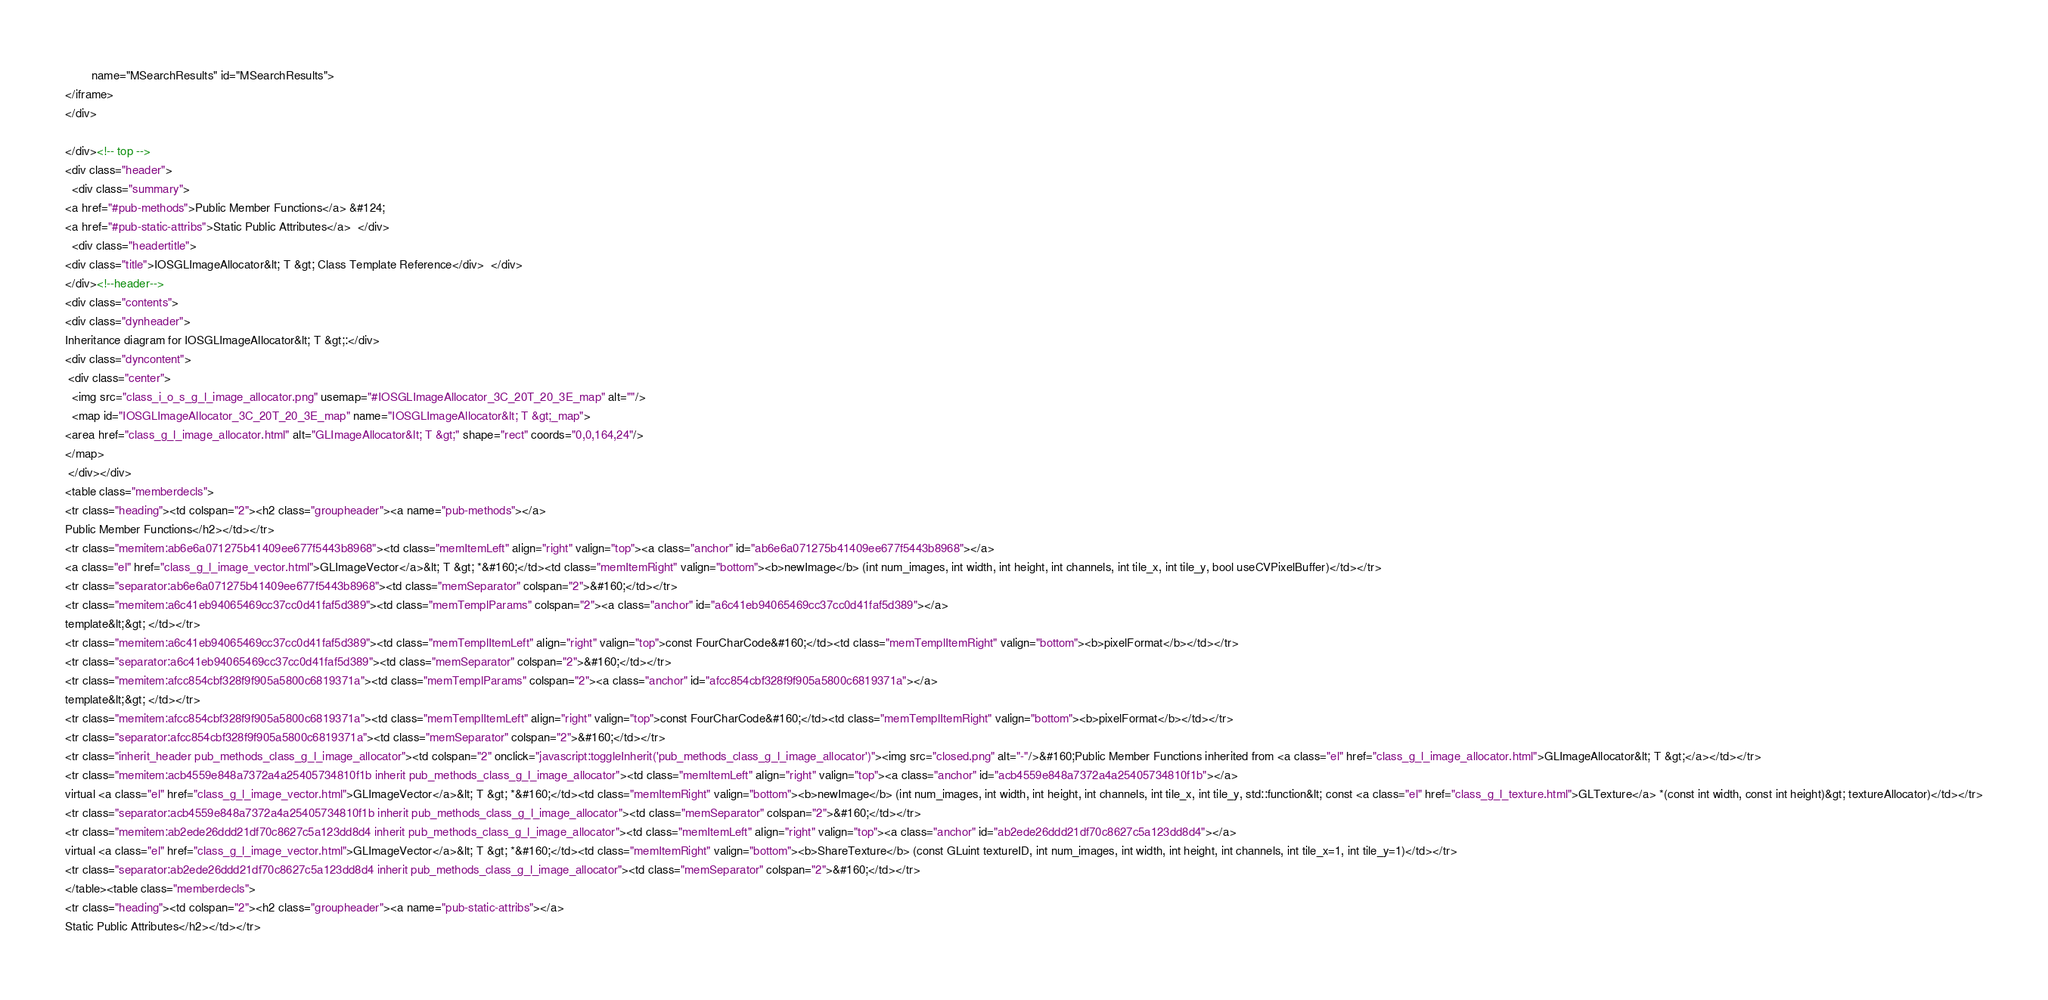Convert code to text. <code><loc_0><loc_0><loc_500><loc_500><_HTML_>        name="MSearchResults" id="MSearchResults">
</iframe>
</div>

</div><!-- top -->
<div class="header">
  <div class="summary">
<a href="#pub-methods">Public Member Functions</a> &#124;
<a href="#pub-static-attribs">Static Public Attributes</a>  </div>
  <div class="headertitle">
<div class="title">IOSGLImageAllocator&lt; T &gt; Class Template Reference</div>  </div>
</div><!--header-->
<div class="contents">
<div class="dynheader">
Inheritance diagram for IOSGLImageAllocator&lt; T &gt;:</div>
<div class="dyncontent">
 <div class="center">
  <img src="class_i_o_s_g_l_image_allocator.png" usemap="#IOSGLImageAllocator_3C_20T_20_3E_map" alt=""/>
  <map id="IOSGLImageAllocator_3C_20T_20_3E_map" name="IOSGLImageAllocator&lt; T &gt;_map">
<area href="class_g_l_image_allocator.html" alt="GLImageAllocator&lt; T &gt;" shape="rect" coords="0,0,164,24"/>
</map>
 </div></div>
<table class="memberdecls">
<tr class="heading"><td colspan="2"><h2 class="groupheader"><a name="pub-methods"></a>
Public Member Functions</h2></td></tr>
<tr class="memitem:ab6e6a071275b41409ee677f5443b8968"><td class="memItemLeft" align="right" valign="top"><a class="anchor" id="ab6e6a071275b41409ee677f5443b8968"></a>
<a class="el" href="class_g_l_image_vector.html">GLImageVector</a>&lt; T &gt; *&#160;</td><td class="memItemRight" valign="bottom"><b>newImage</b> (int num_images, int width, int height, int channels, int tile_x, int tile_y, bool useCVPixelBuffer)</td></tr>
<tr class="separator:ab6e6a071275b41409ee677f5443b8968"><td class="memSeparator" colspan="2">&#160;</td></tr>
<tr class="memitem:a6c41eb94065469cc37cc0d41faf5d389"><td class="memTemplParams" colspan="2"><a class="anchor" id="a6c41eb94065469cc37cc0d41faf5d389"></a>
template&lt;&gt; </td></tr>
<tr class="memitem:a6c41eb94065469cc37cc0d41faf5d389"><td class="memTemplItemLeft" align="right" valign="top">const FourCharCode&#160;</td><td class="memTemplItemRight" valign="bottom"><b>pixelFormat</b></td></tr>
<tr class="separator:a6c41eb94065469cc37cc0d41faf5d389"><td class="memSeparator" colspan="2">&#160;</td></tr>
<tr class="memitem:afcc854cbf328f9f905a5800c6819371a"><td class="memTemplParams" colspan="2"><a class="anchor" id="afcc854cbf328f9f905a5800c6819371a"></a>
template&lt;&gt; </td></tr>
<tr class="memitem:afcc854cbf328f9f905a5800c6819371a"><td class="memTemplItemLeft" align="right" valign="top">const FourCharCode&#160;</td><td class="memTemplItemRight" valign="bottom"><b>pixelFormat</b></td></tr>
<tr class="separator:afcc854cbf328f9f905a5800c6819371a"><td class="memSeparator" colspan="2">&#160;</td></tr>
<tr class="inherit_header pub_methods_class_g_l_image_allocator"><td colspan="2" onclick="javascript:toggleInherit('pub_methods_class_g_l_image_allocator')"><img src="closed.png" alt="-"/>&#160;Public Member Functions inherited from <a class="el" href="class_g_l_image_allocator.html">GLImageAllocator&lt; T &gt;</a></td></tr>
<tr class="memitem:acb4559e848a7372a4a25405734810f1b inherit pub_methods_class_g_l_image_allocator"><td class="memItemLeft" align="right" valign="top"><a class="anchor" id="acb4559e848a7372a4a25405734810f1b"></a>
virtual <a class="el" href="class_g_l_image_vector.html">GLImageVector</a>&lt; T &gt; *&#160;</td><td class="memItemRight" valign="bottom"><b>newImage</b> (int num_images, int width, int height, int channels, int tile_x, int tile_y, std::function&lt; const <a class="el" href="class_g_l_texture.html">GLTexture</a> *(const int width, const int height)&gt; textureAllocator)</td></tr>
<tr class="separator:acb4559e848a7372a4a25405734810f1b inherit pub_methods_class_g_l_image_allocator"><td class="memSeparator" colspan="2">&#160;</td></tr>
<tr class="memitem:ab2ede26ddd21df70c8627c5a123dd8d4 inherit pub_methods_class_g_l_image_allocator"><td class="memItemLeft" align="right" valign="top"><a class="anchor" id="ab2ede26ddd21df70c8627c5a123dd8d4"></a>
virtual <a class="el" href="class_g_l_image_vector.html">GLImageVector</a>&lt; T &gt; *&#160;</td><td class="memItemRight" valign="bottom"><b>ShareTexture</b> (const GLuint textureID, int num_images, int width, int height, int channels, int tile_x=1, int tile_y=1)</td></tr>
<tr class="separator:ab2ede26ddd21df70c8627c5a123dd8d4 inherit pub_methods_class_g_l_image_allocator"><td class="memSeparator" colspan="2">&#160;</td></tr>
</table><table class="memberdecls">
<tr class="heading"><td colspan="2"><h2 class="groupheader"><a name="pub-static-attribs"></a>
Static Public Attributes</h2></td></tr></code> 